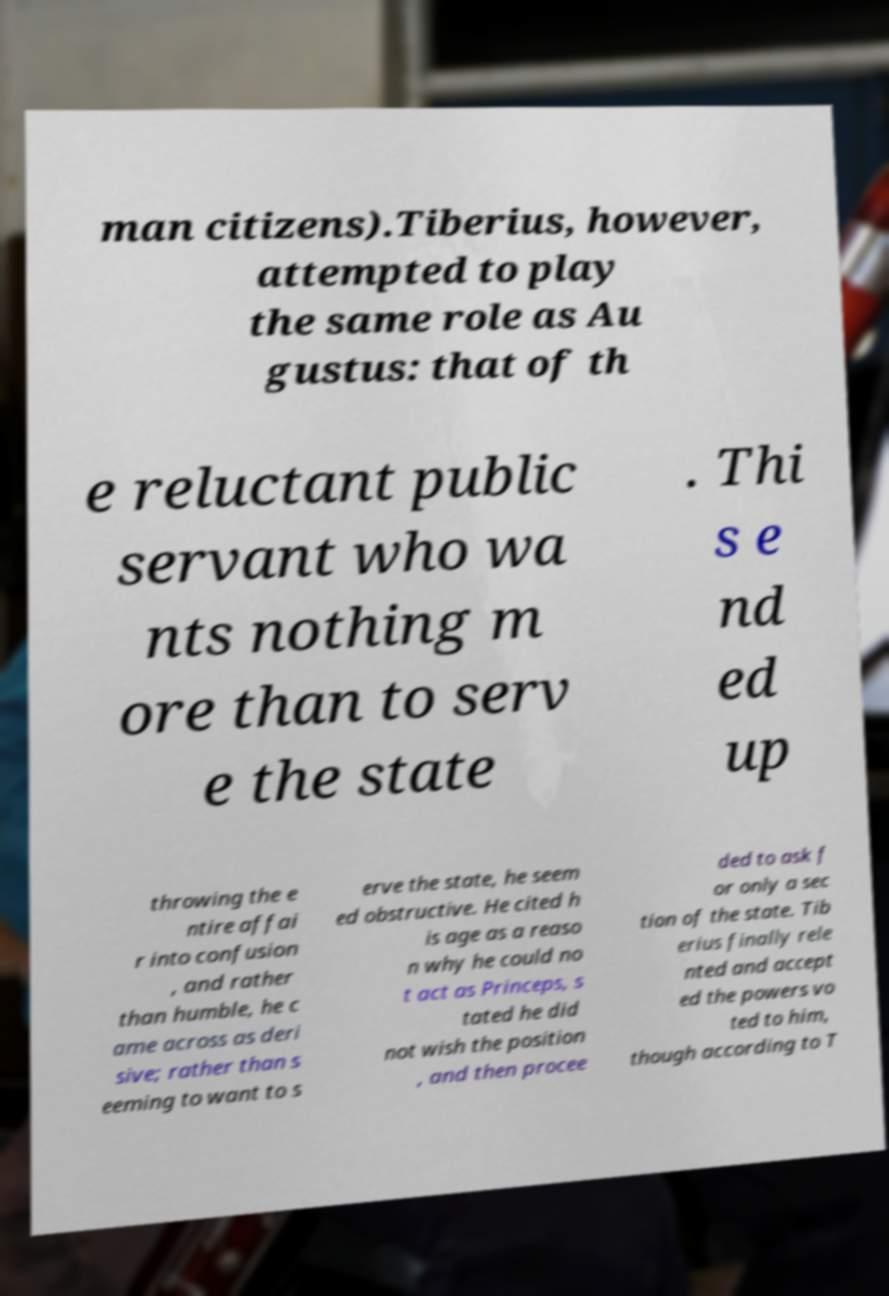Please identify and transcribe the text found in this image. man citizens).Tiberius, however, attempted to play the same role as Au gustus: that of th e reluctant public servant who wa nts nothing m ore than to serv e the state . Thi s e nd ed up throwing the e ntire affai r into confusion , and rather than humble, he c ame across as deri sive; rather than s eeming to want to s erve the state, he seem ed obstructive. He cited h is age as a reaso n why he could no t act as Princeps, s tated he did not wish the position , and then procee ded to ask f or only a sec tion of the state. Tib erius finally rele nted and accept ed the powers vo ted to him, though according to T 